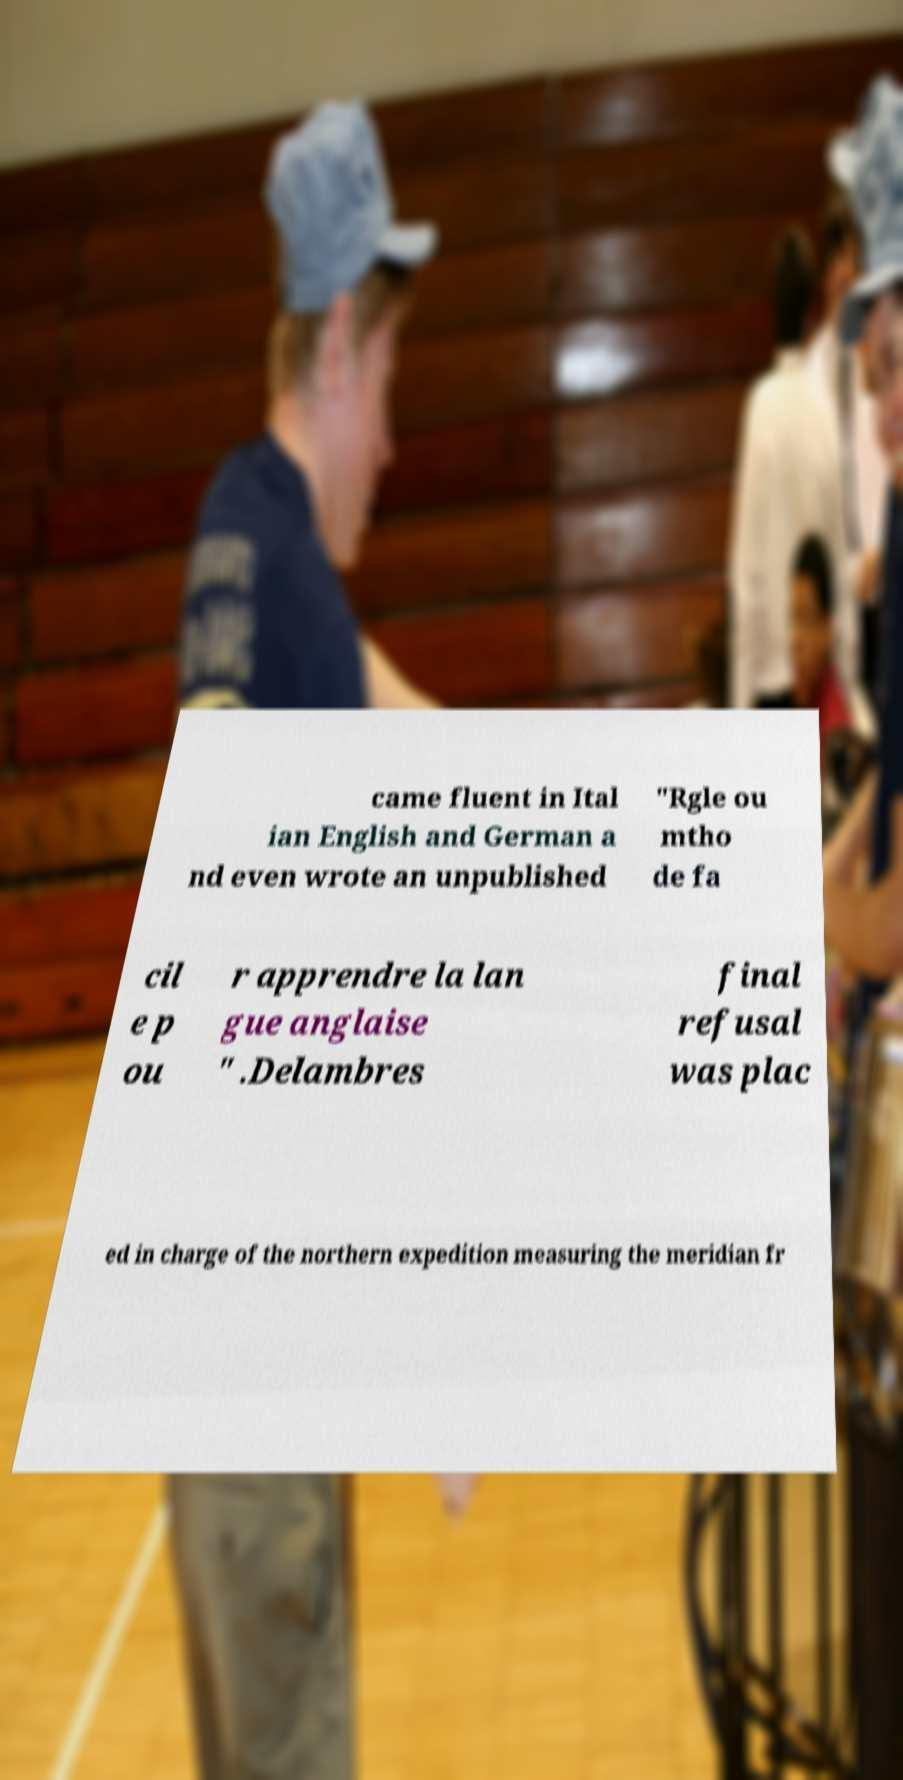For documentation purposes, I need the text within this image transcribed. Could you provide that? came fluent in Ital ian English and German a nd even wrote an unpublished "Rgle ou mtho de fa cil e p ou r apprendre la lan gue anglaise " .Delambres final refusal was plac ed in charge of the northern expedition measuring the meridian fr 